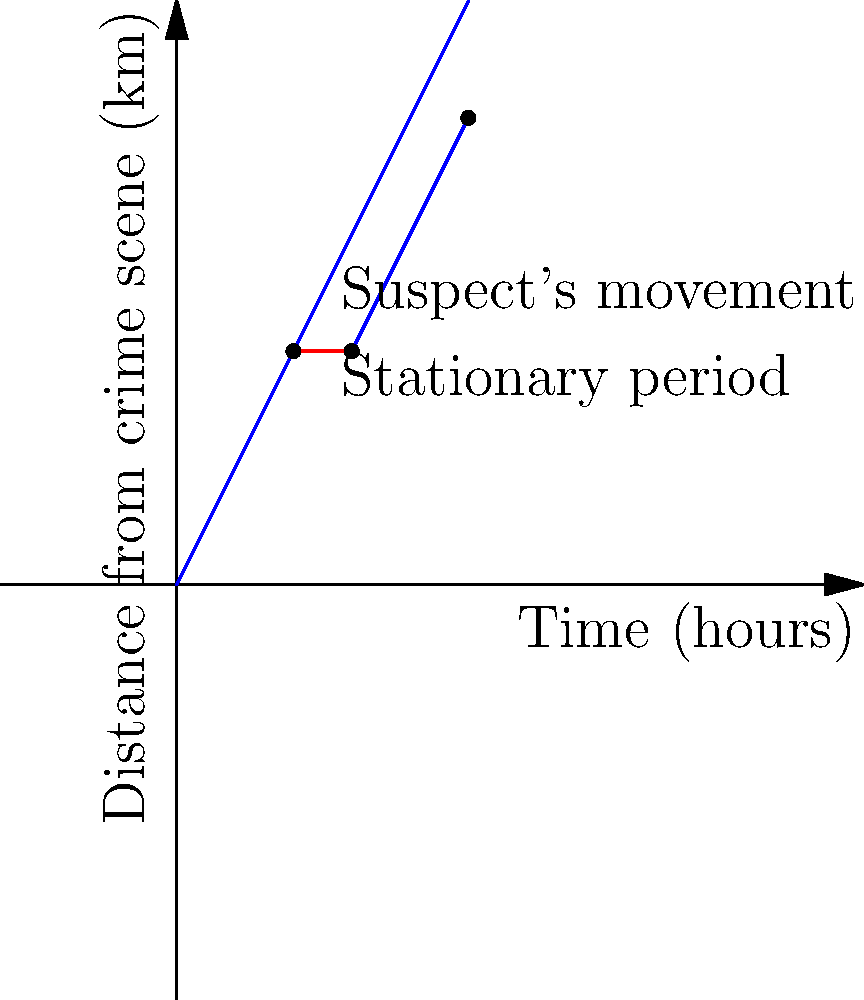Based on the time-distance graph of a suspect's alibi, at what time did the suspect pause their movement, and for how long? To solve this problem, we need to analyze the graph carefully:

1. The blue line represents the suspect's movement over time.
2. The horizontal red line segment indicates a period where the distance from the crime scene doesn't change, meaning the suspect was stationary.

To find the time when the suspect paused:
1. Locate the start of the horizontal line segment on the x-axis (Time axis).
   This occurs at $x = 2$ hours.

To determine how long the suspect remained stationary:
1. Find the end of the horizontal line segment on the x-axis.
   This occurs at $x = 3$ hours.
2. Calculate the difference: $3 - 2 = 1$ hour.

Therefore, the suspect paused their movement at 2 hours after the reference time and remained stationary for 1 hour.
Answer: 2 hours after reference time, for 1 hour 